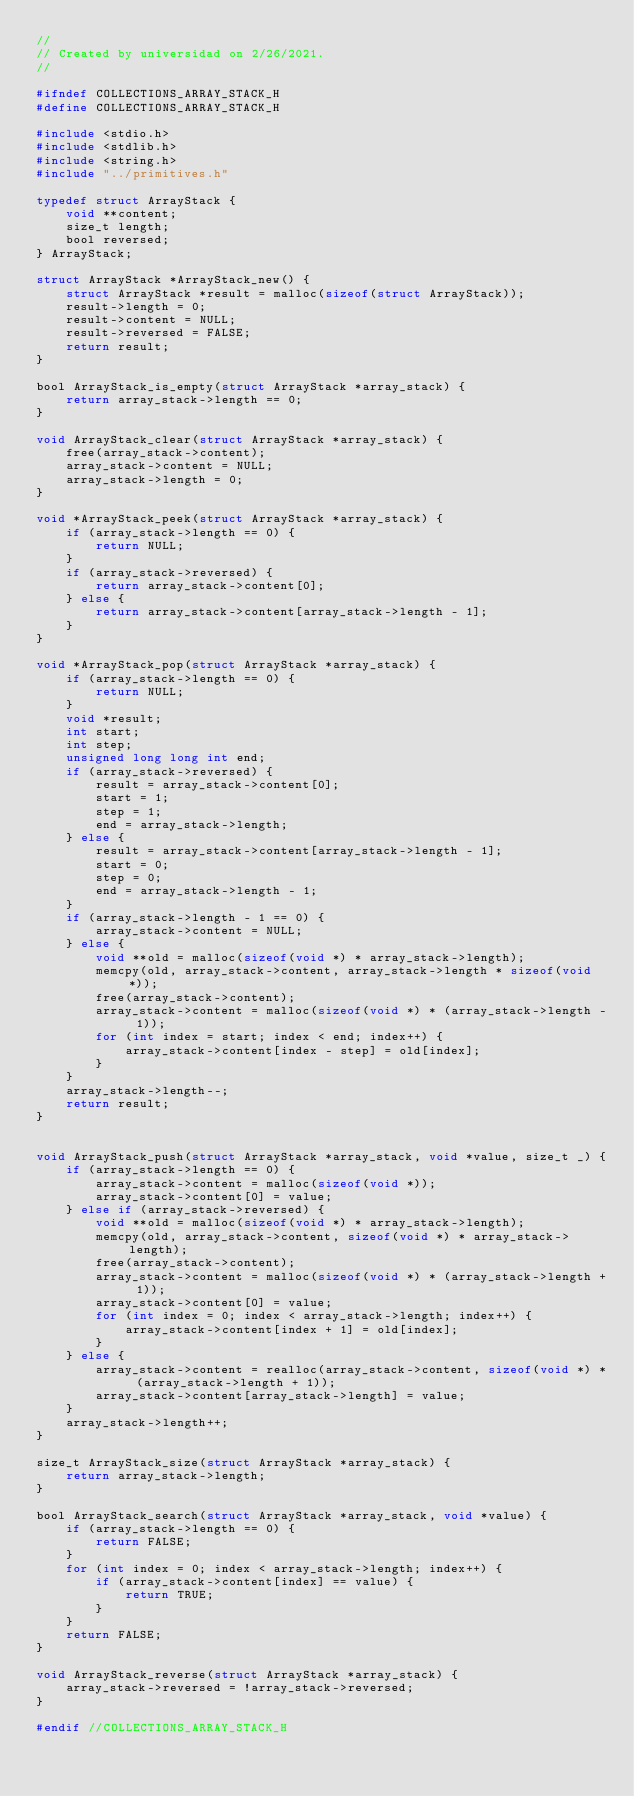Convert code to text. <code><loc_0><loc_0><loc_500><loc_500><_C_>//
// Created by universidad on 2/26/2021.
//

#ifndef COLLECTIONS_ARRAY_STACK_H
#define COLLECTIONS_ARRAY_STACK_H

#include <stdio.h>
#include <stdlib.h>
#include <string.h>
#include "../primitives.h"

typedef struct ArrayStack {
    void **content;
    size_t length;
    bool reversed;
} ArrayStack;

struct ArrayStack *ArrayStack_new() {
    struct ArrayStack *result = malloc(sizeof(struct ArrayStack));
    result->length = 0;
    result->content = NULL;
    result->reversed = FALSE;
    return result;
}

bool ArrayStack_is_empty(struct ArrayStack *array_stack) {
    return array_stack->length == 0;
}

void ArrayStack_clear(struct ArrayStack *array_stack) {
    free(array_stack->content);
    array_stack->content = NULL;
    array_stack->length = 0;
}

void *ArrayStack_peek(struct ArrayStack *array_stack) {
    if (array_stack->length == 0) {
        return NULL;
    }
    if (array_stack->reversed) {
        return array_stack->content[0];
    } else {
        return array_stack->content[array_stack->length - 1];
    }
}

void *ArrayStack_pop(struct ArrayStack *array_stack) {
    if (array_stack->length == 0) {
        return NULL;
    }
    void *result;
    int start;
    int step;
    unsigned long long int end;
    if (array_stack->reversed) {
        result = array_stack->content[0];
        start = 1;
        step = 1;
        end = array_stack->length;
    } else {
        result = array_stack->content[array_stack->length - 1];
        start = 0;
        step = 0;
        end = array_stack->length - 1;
    }
    if (array_stack->length - 1 == 0) {
        array_stack->content = NULL;
    } else {
        void **old = malloc(sizeof(void *) * array_stack->length);
        memcpy(old, array_stack->content, array_stack->length * sizeof(void *));
        free(array_stack->content);
        array_stack->content = malloc(sizeof(void *) * (array_stack->length - 1));
        for (int index = start; index < end; index++) {
            array_stack->content[index - step] = old[index];
        }
    }
    array_stack->length--;
    return result;
}


void ArrayStack_push(struct ArrayStack *array_stack, void *value, size_t _) {
    if (array_stack->length == 0) {
        array_stack->content = malloc(sizeof(void *));
        array_stack->content[0] = value;
    } else if (array_stack->reversed) {
        void **old = malloc(sizeof(void *) * array_stack->length);
        memcpy(old, array_stack->content, sizeof(void *) * array_stack->length);
        free(array_stack->content);
        array_stack->content = malloc(sizeof(void *) * (array_stack->length + 1));
        array_stack->content[0] = value;
        for (int index = 0; index < array_stack->length; index++) {
            array_stack->content[index + 1] = old[index];
        }
    } else {
        array_stack->content = realloc(array_stack->content, sizeof(void *) * (array_stack->length + 1));
        array_stack->content[array_stack->length] = value;
    }
    array_stack->length++;
}

size_t ArrayStack_size(struct ArrayStack *array_stack) {
    return array_stack->length;
}

bool ArrayStack_search(struct ArrayStack *array_stack, void *value) {
    if (array_stack->length == 0) {
        return FALSE;
    }
    for (int index = 0; index < array_stack->length; index++) {
        if (array_stack->content[index] == value) {
            return TRUE;
        }
    }
    return FALSE;
}

void ArrayStack_reverse(struct ArrayStack *array_stack) {
    array_stack->reversed = !array_stack->reversed;
}

#endif //COLLECTIONS_ARRAY_STACK_H
</code> 